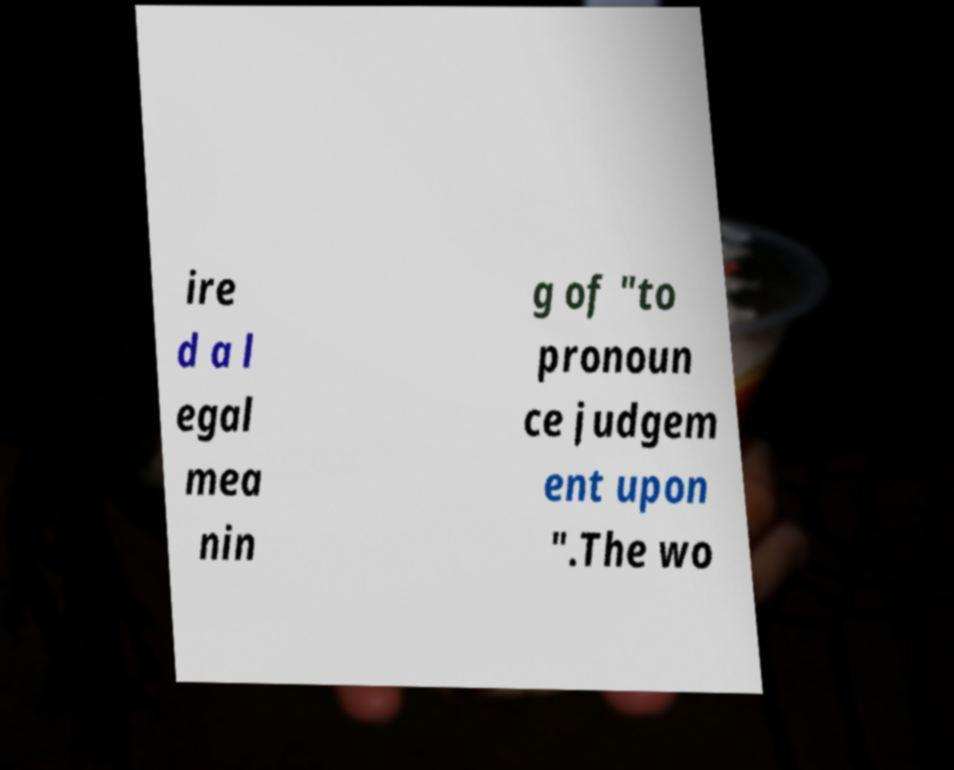For documentation purposes, I need the text within this image transcribed. Could you provide that? ire d a l egal mea nin g of "to pronoun ce judgem ent upon ".The wo 